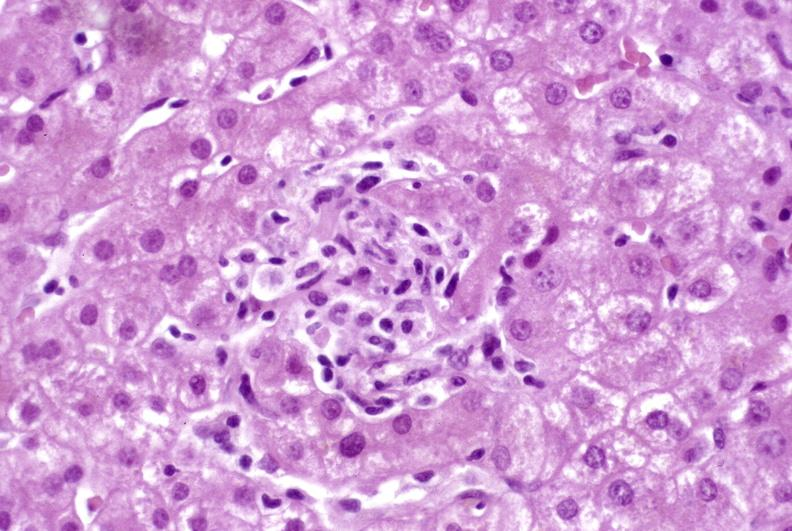what is present?
Answer the question using a single word or phrase. Liver 